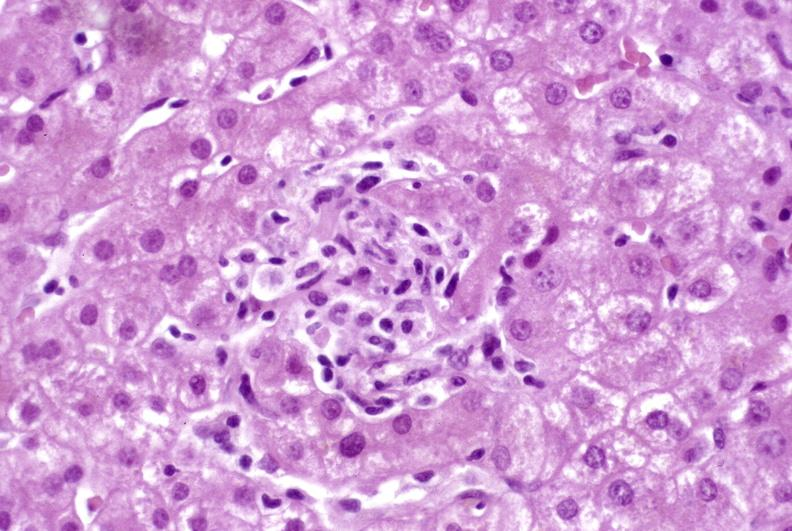what is present?
Answer the question using a single word or phrase. Liver 